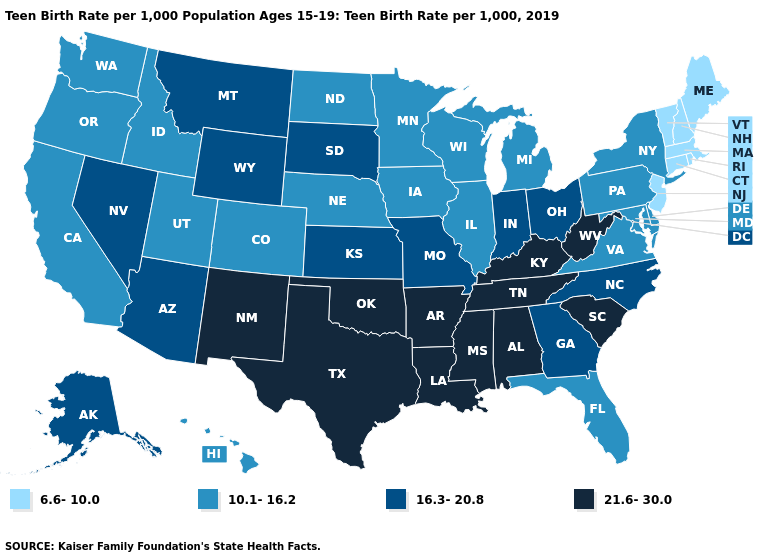What is the highest value in states that border Minnesota?
Answer briefly. 16.3-20.8. What is the value of New York?
Write a very short answer. 10.1-16.2. Does South Carolina have the same value as Colorado?
Keep it brief. No. Does Georgia have a lower value than Indiana?
Concise answer only. No. What is the value of Nebraska?
Quick response, please. 10.1-16.2. Among the states that border Georgia , which have the lowest value?
Write a very short answer. Florida. What is the highest value in the Northeast ?
Keep it brief. 10.1-16.2. What is the value of Utah?
Give a very brief answer. 10.1-16.2. Which states have the highest value in the USA?
Keep it brief. Alabama, Arkansas, Kentucky, Louisiana, Mississippi, New Mexico, Oklahoma, South Carolina, Tennessee, Texas, West Virginia. How many symbols are there in the legend?
Answer briefly. 4. Does Washington have a higher value than New Mexico?
Give a very brief answer. No. Does Missouri have the highest value in the MidWest?
Be succinct. Yes. Does New York have the lowest value in the USA?
Concise answer only. No. Does New Mexico have the lowest value in the West?
Answer briefly. No. Does the first symbol in the legend represent the smallest category?
Give a very brief answer. Yes. 